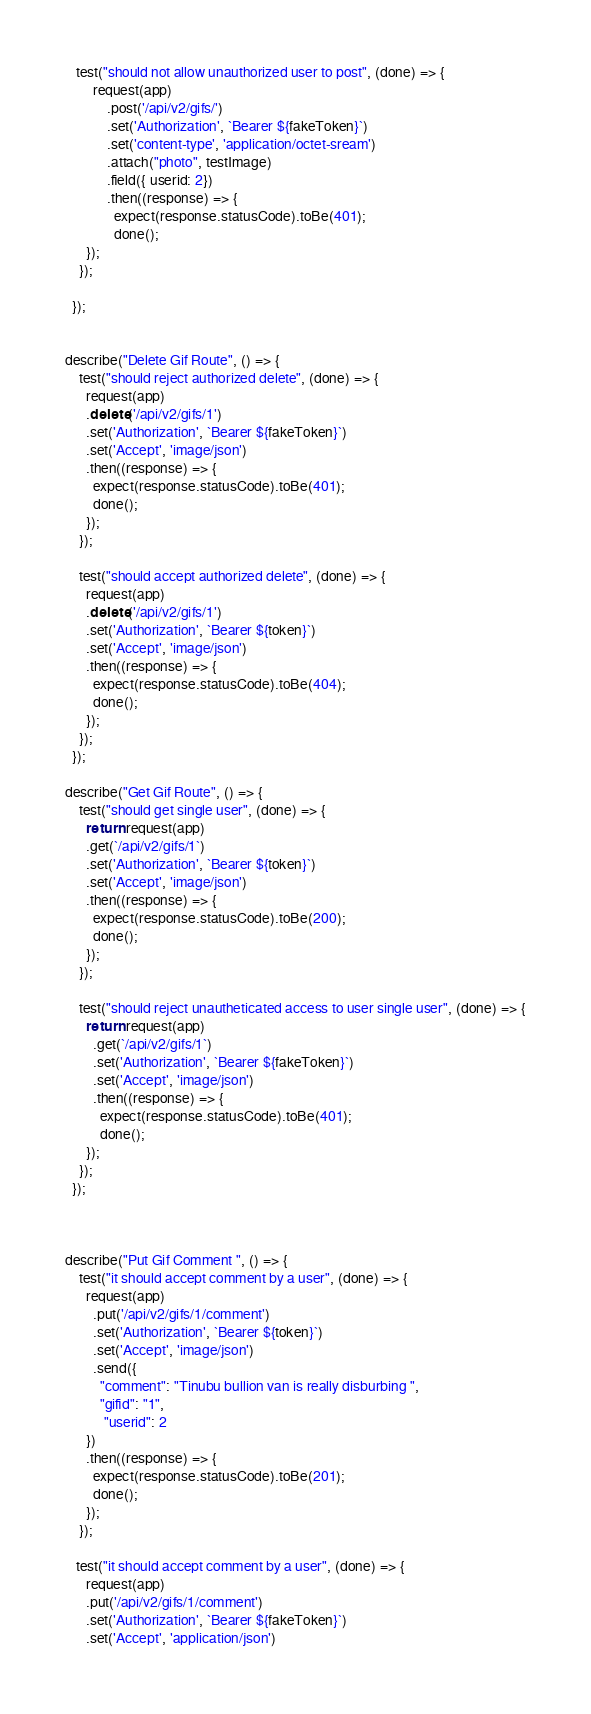<code> <loc_0><loc_0><loc_500><loc_500><_JavaScript_>   test("should not allow unauthorized user to post", (done) => {
        request(app)
            .post('/api/v2/gifs/')
            .set('Authorization', `Bearer ${fakeToken}`)
            .set('content-type', 'application/octet-sream')
            .attach("photo", testImage)
            .field({ userid: 2})
            .then((response) => {
              expect(response.statusCode).toBe(401);
              done();
      });
    });

  });


describe("Delete Gif Route", () => {
    test("should reject authorized delete", (done) => {
      request(app)
      .delete('/api/v2/gifs/1')
      .set('Authorization', `Bearer ${fakeToken}`)
      .set('Accept', 'image/json')
      .then((response) => {
        expect(response.statusCode).toBe(401);
        done();
      });
    });

    test("should accept authorized delete", (done) => {
      request(app)
      .delete('/api/v2/gifs/1')
      .set('Authorization', `Bearer ${token}`)
      .set('Accept', 'image/json')
      .then((response) => {
        expect(response.statusCode).toBe(404);
        done();
      });
    });
  });

describe("Get Gif Route", () => {
    test("should get single user", (done) => {
      return request(app)
      .get(`/api/v2/gifs/1`)
      .set('Authorization', `Bearer ${token}`)
      .set('Accept', 'image/json')
      .then((response) => {
        expect(response.statusCode).toBe(200);
        done();
      });
    });

    test("should reject unautheticated access to user single user", (done) => {
      return request(app)
        .get(`/api/v2/gifs/1`)
        .set('Authorization', `Bearer ${fakeToken}`)
        .set('Accept', 'image/json')
        .then((response) => {
          expect(response.statusCode).toBe(401);
          done();
      });
    });
  });



describe("Put Gif Comment ", () => {
    test("it should accept comment by a user", (done) => {
      request(app)
        .put('/api/v2/gifs/1/comment')
        .set('Authorization', `Bearer ${token}`)
        .set('Accept', 'image/json')
        .send({
          "comment": "Tinubu bullion van is really disburbing ",
          "gifid": "1",
           "userid": 2
      })
      .then((response) => {
        expect(response.statusCode).toBe(201);
        done();
      });
    });

   test("it should accept comment by a user", (done) => {
      request(app)
      .put('/api/v2/gifs/1/comment')
      .set('Authorization', `Bearer ${fakeToken}`)
      .set('Accept', 'application/json')</code> 